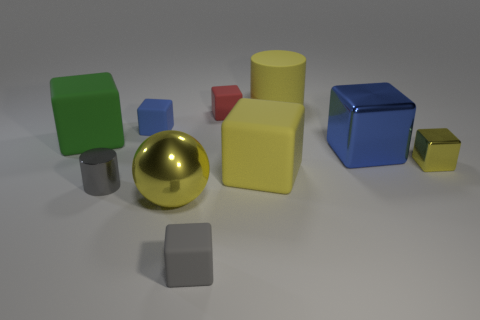Subtract all cylinders. How many objects are left? 8 Subtract 5 blocks. How many blocks are left? 2 Subtract all red blocks. How many blocks are left? 6 Subtract all large cubes. How many cubes are left? 4 Subtract 1 gray cylinders. How many objects are left? 9 Subtract all red spheres. Subtract all red cubes. How many spheres are left? 1 Subtract all purple spheres. How many red cubes are left? 1 Subtract all green cubes. Subtract all tiny red objects. How many objects are left? 8 Add 3 small blue blocks. How many small blue blocks are left? 4 Add 10 big blue rubber balls. How many big blue rubber balls exist? 10 